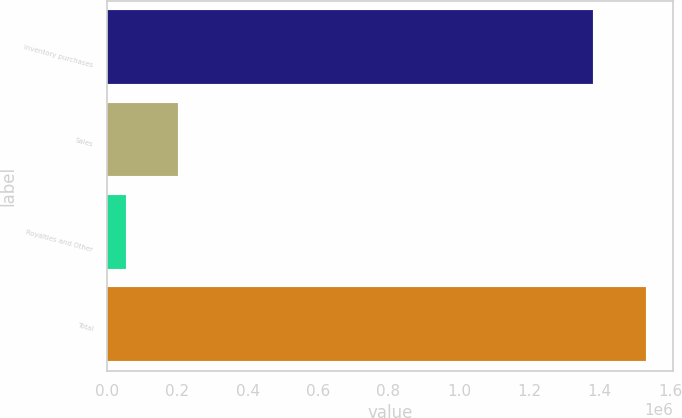Convert chart. <chart><loc_0><loc_0><loc_500><loc_500><bar_chart><fcel>Inventory purchases<fcel>Sales<fcel>Royalties and Other<fcel>Total<nl><fcel>1.38049e+06<fcel>202144<fcel>54360<fcel>1.5322e+06<nl></chart> 